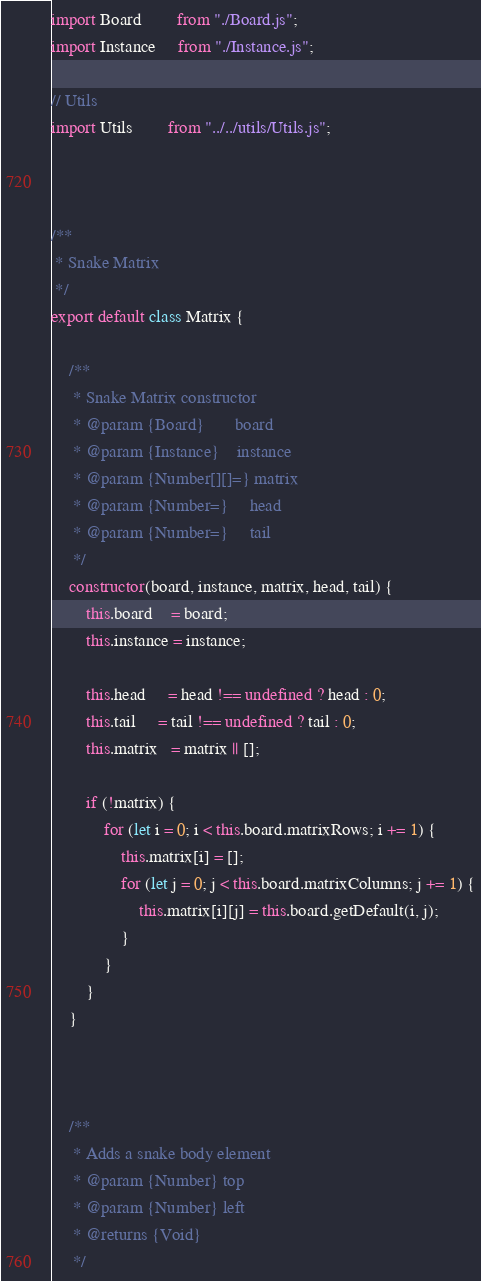<code> <loc_0><loc_0><loc_500><loc_500><_JavaScript_>import Board        from "./Board.js";
import Instance     from "./Instance.js";

// Utils
import Utils        from "../../utils/Utils.js";



/**
 * Snake Matrix
 */
export default class Matrix {

    /**
     * Snake Matrix constructor
     * @param {Board}       board
     * @param {Instance}    instance
     * @param {Number[][]=} matrix
     * @param {Number=}     head
     * @param {Number=}     tail
     */
    constructor(board, instance, matrix, head, tail) {
        this.board    = board;
        this.instance = instance;

        this.head     = head !== undefined ? head : 0;
        this.tail     = tail !== undefined ? tail : 0;
        this.matrix   = matrix || [];

        if (!matrix) {
            for (let i = 0; i < this.board.matrixRows; i += 1) {
                this.matrix[i] = [];
                for (let j = 0; j < this.board.matrixColumns; j += 1) {
                    this.matrix[i][j] = this.board.getDefault(i, j);
                }
            }
        }
    }



    /**
     * Adds a snake body element
     * @param {Number} top
     * @param {Number} left
     * @returns {Void}
     */</code> 